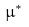Convert formula to latex. <formula><loc_0><loc_0><loc_500><loc_500>\mu ^ { \ast }</formula> 